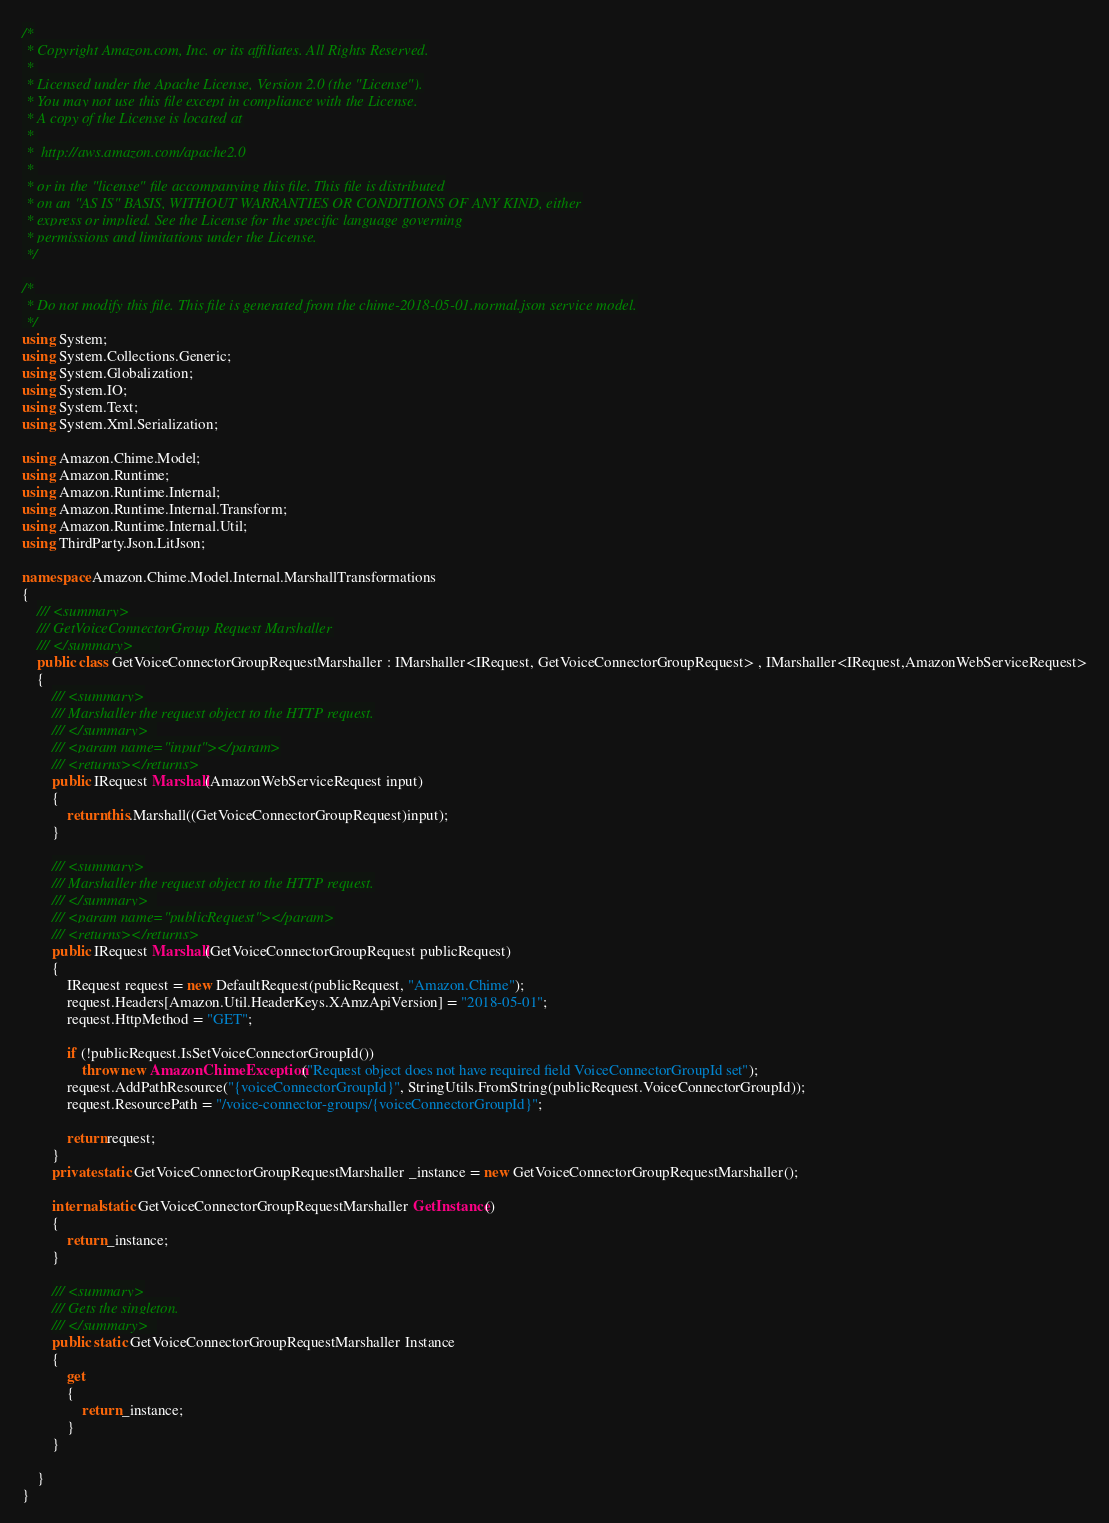<code> <loc_0><loc_0><loc_500><loc_500><_C#_>/*
 * Copyright Amazon.com, Inc. or its affiliates. All Rights Reserved.
 * 
 * Licensed under the Apache License, Version 2.0 (the "License").
 * You may not use this file except in compliance with the License.
 * A copy of the License is located at
 * 
 *  http://aws.amazon.com/apache2.0
 * 
 * or in the "license" file accompanying this file. This file is distributed
 * on an "AS IS" BASIS, WITHOUT WARRANTIES OR CONDITIONS OF ANY KIND, either
 * express or implied. See the License for the specific language governing
 * permissions and limitations under the License.
 */

/*
 * Do not modify this file. This file is generated from the chime-2018-05-01.normal.json service model.
 */
using System;
using System.Collections.Generic;
using System.Globalization;
using System.IO;
using System.Text;
using System.Xml.Serialization;

using Amazon.Chime.Model;
using Amazon.Runtime;
using Amazon.Runtime.Internal;
using Amazon.Runtime.Internal.Transform;
using Amazon.Runtime.Internal.Util;
using ThirdParty.Json.LitJson;

namespace Amazon.Chime.Model.Internal.MarshallTransformations
{
    /// <summary>
    /// GetVoiceConnectorGroup Request Marshaller
    /// </summary>       
    public class GetVoiceConnectorGroupRequestMarshaller : IMarshaller<IRequest, GetVoiceConnectorGroupRequest> , IMarshaller<IRequest,AmazonWebServiceRequest>
    {
        /// <summary>
        /// Marshaller the request object to the HTTP request.
        /// </summary>  
        /// <param name="input"></param>
        /// <returns></returns>
        public IRequest Marshall(AmazonWebServiceRequest input)
        {
            return this.Marshall((GetVoiceConnectorGroupRequest)input);
        }

        /// <summary>
        /// Marshaller the request object to the HTTP request.
        /// </summary>  
        /// <param name="publicRequest"></param>
        /// <returns></returns>
        public IRequest Marshall(GetVoiceConnectorGroupRequest publicRequest)
        {
            IRequest request = new DefaultRequest(publicRequest, "Amazon.Chime");
            request.Headers[Amazon.Util.HeaderKeys.XAmzApiVersion] = "2018-05-01";
            request.HttpMethod = "GET";

            if (!publicRequest.IsSetVoiceConnectorGroupId())
                throw new AmazonChimeException("Request object does not have required field VoiceConnectorGroupId set");
            request.AddPathResource("{voiceConnectorGroupId}", StringUtils.FromString(publicRequest.VoiceConnectorGroupId));
            request.ResourcePath = "/voice-connector-groups/{voiceConnectorGroupId}";

            return request;
        }
        private static GetVoiceConnectorGroupRequestMarshaller _instance = new GetVoiceConnectorGroupRequestMarshaller();        

        internal static GetVoiceConnectorGroupRequestMarshaller GetInstance()
        {
            return _instance;
        }

        /// <summary>
        /// Gets the singleton.
        /// </summary>  
        public static GetVoiceConnectorGroupRequestMarshaller Instance
        {
            get
            {
                return _instance;
            }
        }

    }
}</code> 